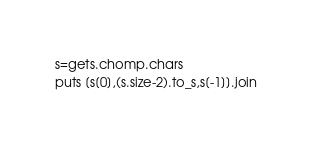Convert code to text. <code><loc_0><loc_0><loc_500><loc_500><_Ruby_>s=gets.chomp.chars
puts [s[0],(s.size-2).to_s,s[-1]].join</code> 